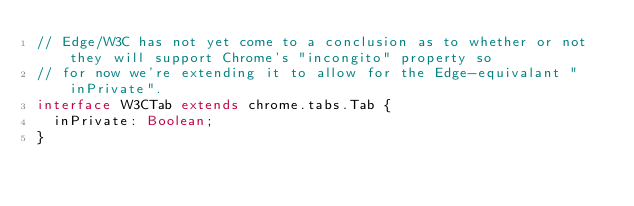<code> <loc_0><loc_0><loc_500><loc_500><_TypeScript_>// Edge/W3C has not yet come to a conclusion as to whether or not they will support Chrome's "incongito" property so
// for now we're extending it to allow for the Edge-equivalant "inPrivate".
interface W3CTab extends chrome.tabs.Tab {
	inPrivate: Boolean;
}
</code> 